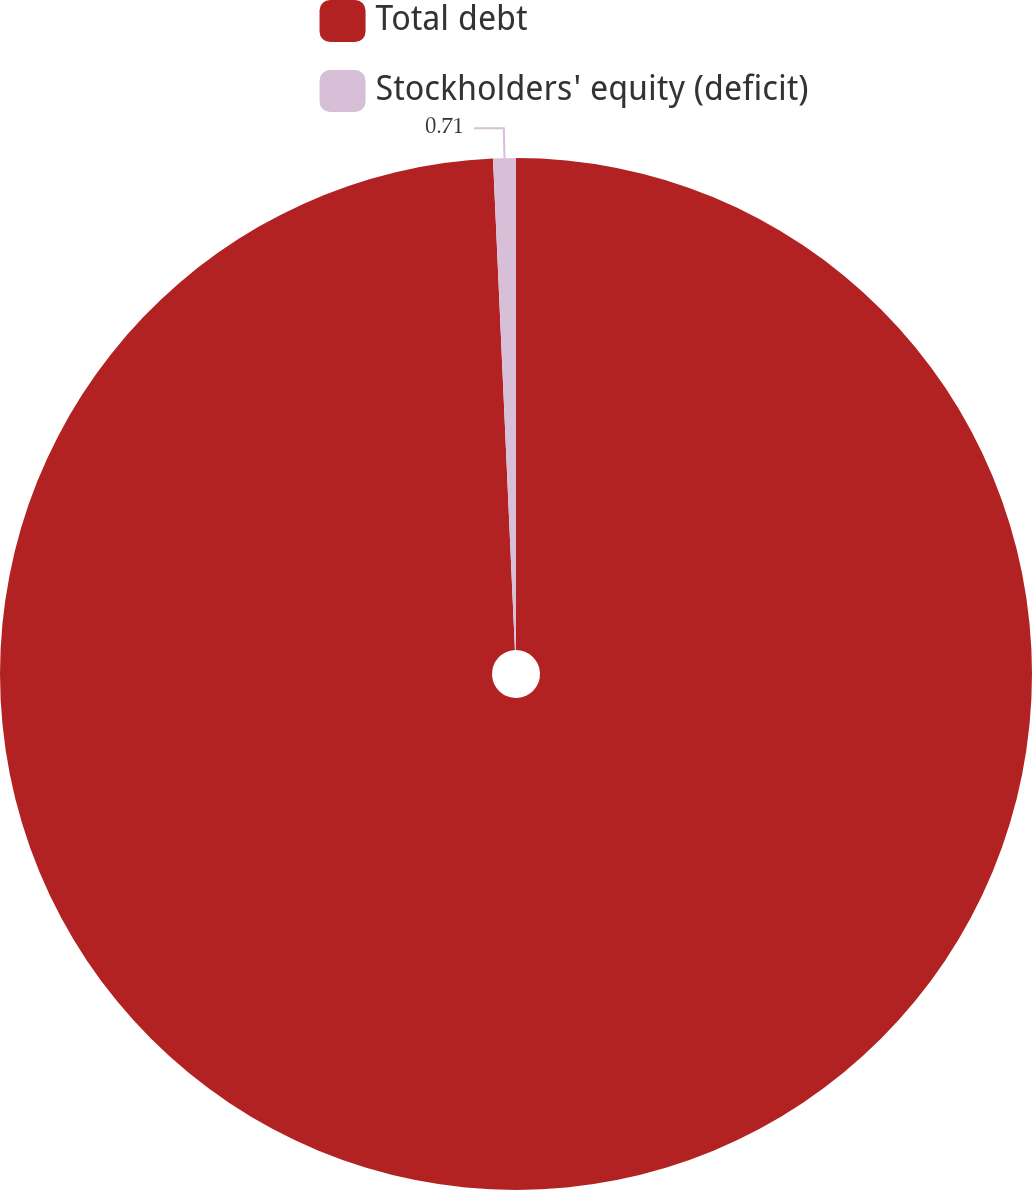Convert chart. <chart><loc_0><loc_0><loc_500><loc_500><pie_chart><fcel>Total debt<fcel>Stockholders' equity (deficit)<nl><fcel>99.29%<fcel>0.71%<nl></chart> 